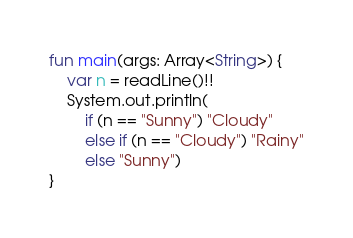Convert code to text. <code><loc_0><loc_0><loc_500><loc_500><_Kotlin_>fun main(args: Array<String>) {
    var n = readLine()!!
    System.out.println(
        if (n == "Sunny") "Cloudy"
        else if (n == "Cloudy") "Rainy"
        else "Sunny")
}
</code> 